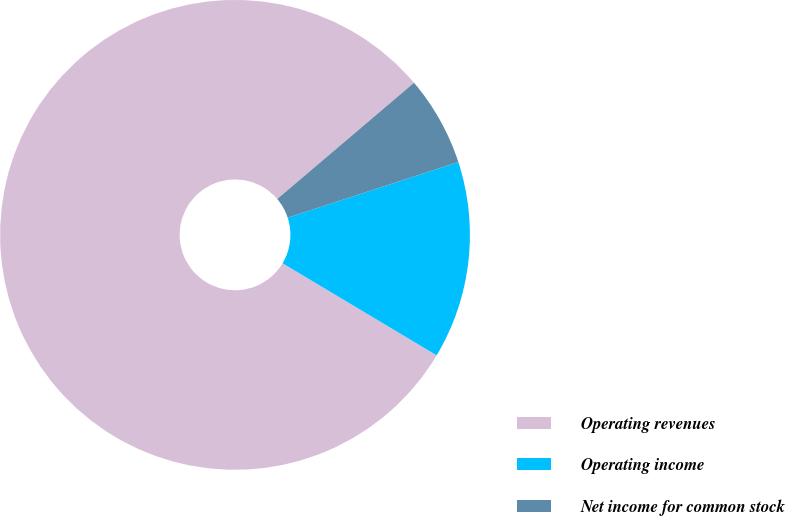<chart> <loc_0><loc_0><loc_500><loc_500><pie_chart><fcel>Operating revenues<fcel>Operating income<fcel>Net income for common stock<nl><fcel>80.22%<fcel>13.59%<fcel>6.19%<nl></chart> 